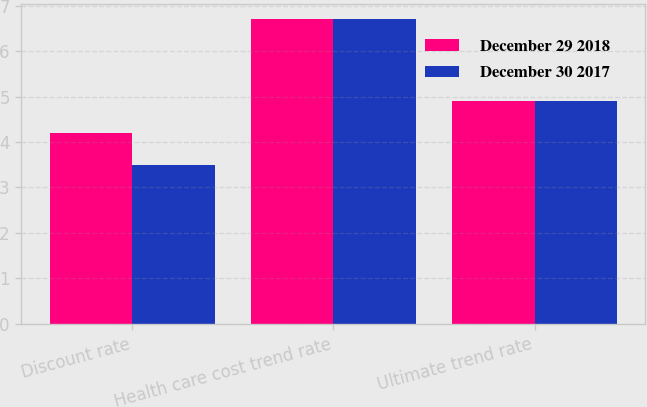<chart> <loc_0><loc_0><loc_500><loc_500><stacked_bar_chart><ecel><fcel>Discount rate<fcel>Health care cost trend rate<fcel>Ultimate trend rate<nl><fcel>December 29 2018<fcel>4.2<fcel>6.7<fcel>4.9<nl><fcel>December 30 2017<fcel>3.5<fcel>6.7<fcel>4.9<nl></chart> 